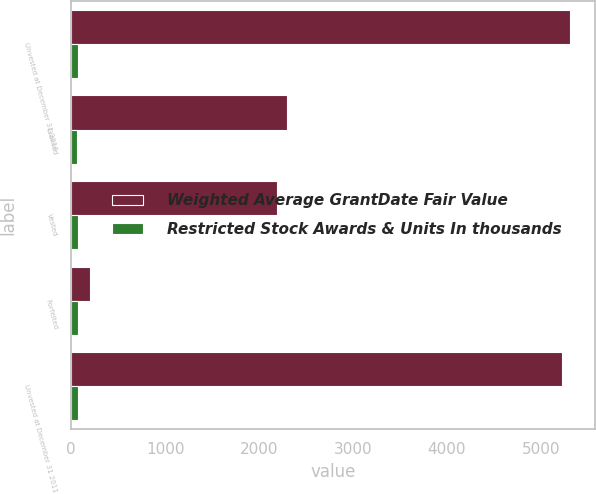Convert chart to OTSL. <chart><loc_0><loc_0><loc_500><loc_500><stacked_bar_chart><ecel><fcel>Unvested at December 31 2010<fcel>Granted<fcel>Vested<fcel>Forfeited<fcel>Unvested at December 31 2011<nl><fcel>Weighted Average GrantDate Fair Value<fcel>5311<fcel>2301<fcel>2188<fcel>200<fcel>5224<nl><fcel>Restricted Stock Awards & Units In thousands<fcel>70.6<fcel>65.4<fcel>72.05<fcel>71.18<fcel>67.85<nl></chart> 